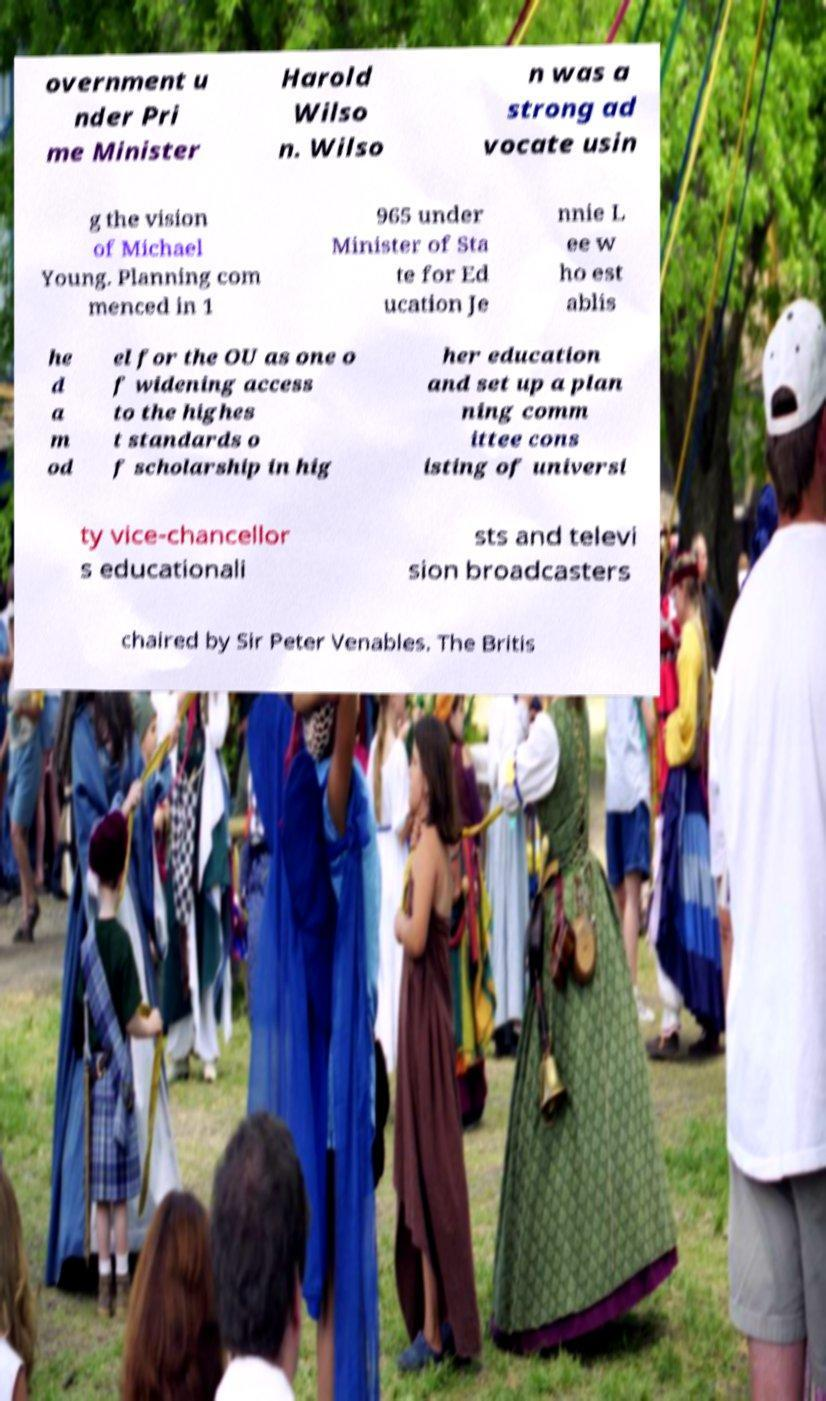Please identify and transcribe the text found in this image. overnment u nder Pri me Minister Harold Wilso n. Wilso n was a strong ad vocate usin g the vision of Michael Young. Planning com menced in 1 965 under Minister of Sta te for Ed ucation Je nnie L ee w ho est ablis he d a m od el for the OU as one o f widening access to the highes t standards o f scholarship in hig her education and set up a plan ning comm ittee cons isting of universi ty vice-chancellor s educationali sts and televi sion broadcasters chaired by Sir Peter Venables. The Britis 